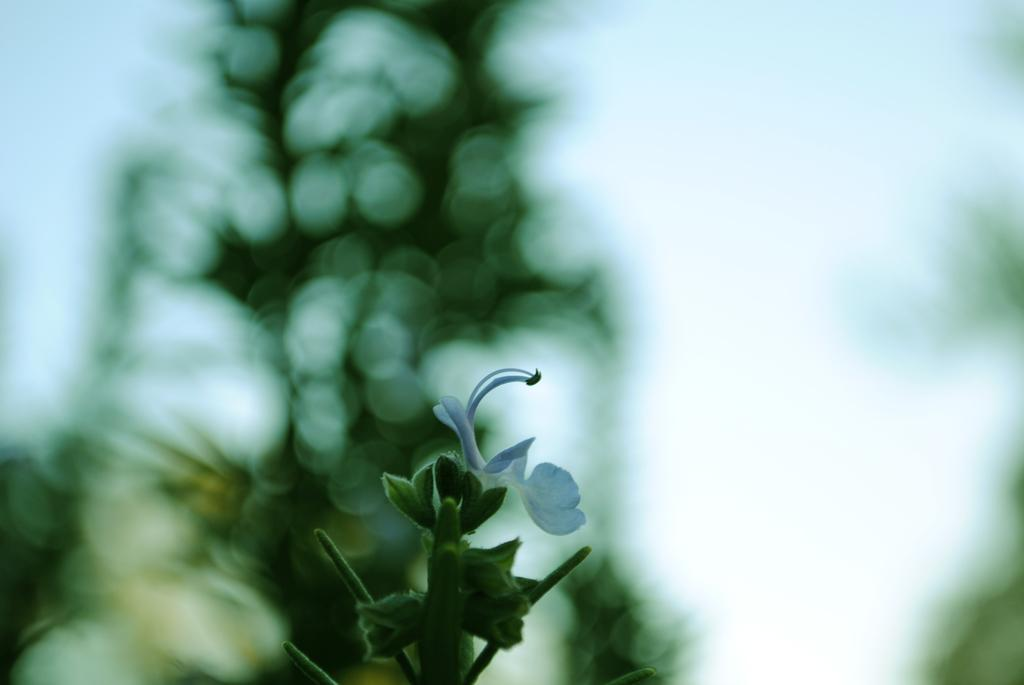Where was the image taken? The image was taken outdoors. What can be observed about the background of the image? The background of the image is blurred. What is the main subject in the image? There is a plant in the middle of the image. What is special about the plant in the image? The plant has a white flower on it. What type of produce is being sold at the school in the image? There is no school or produce present in the image; it features a plant with a white flower. What color is the ball that is being used to play with in the image? There is no ball present in the image; it features a plant with a white flower. 